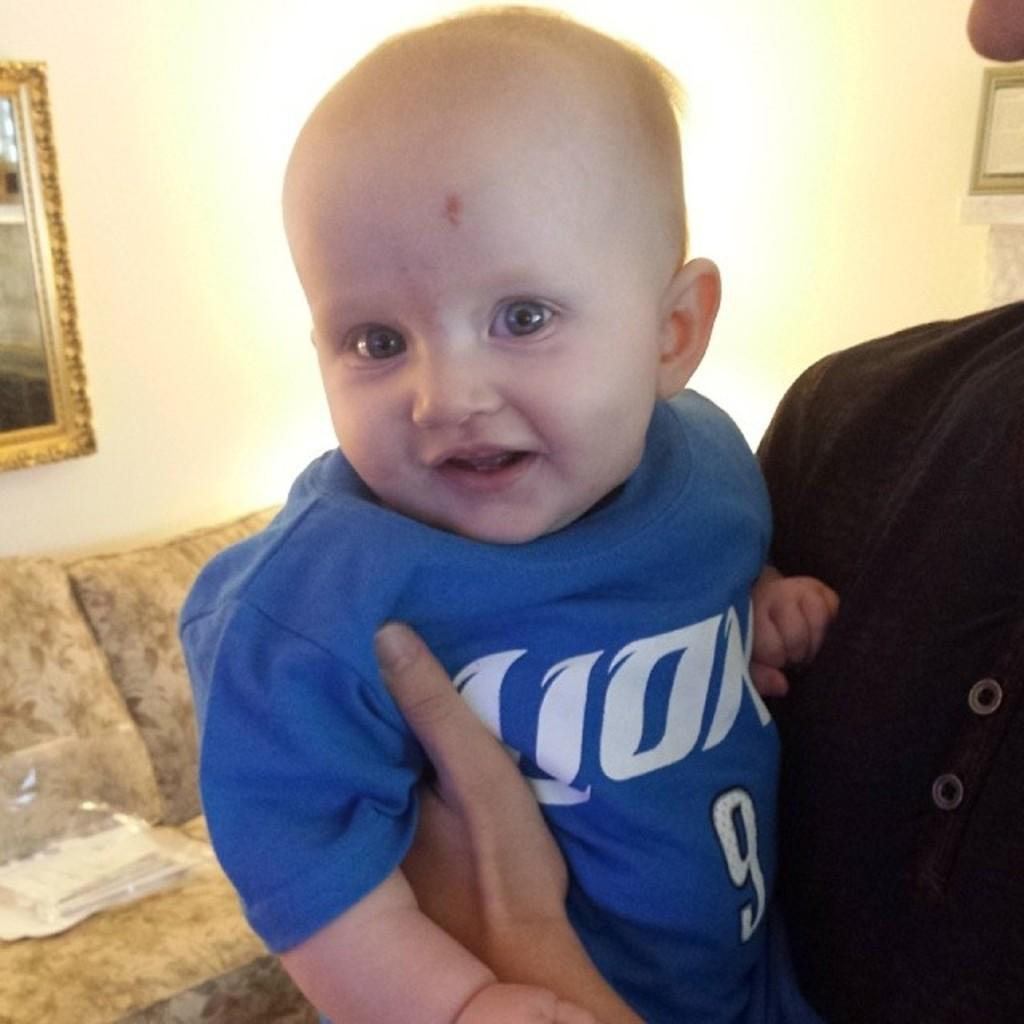<image>
Relay a brief, clear account of the picture shown. a baby wearing a 9 onsie has a mark on its head 